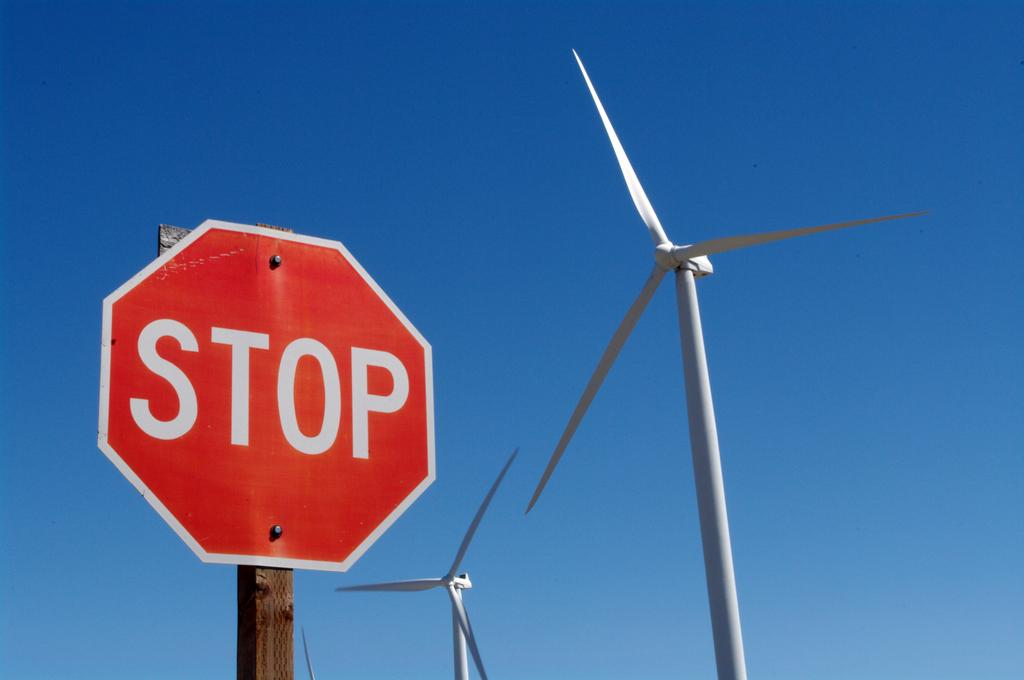<image>
Describe the image concisely. A stop sign stands in front of 2 windmills. 